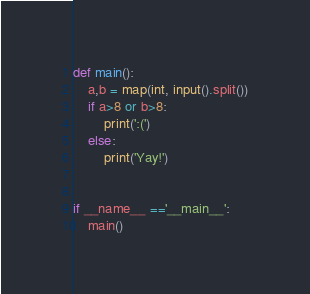<code> <loc_0><loc_0><loc_500><loc_500><_Python_>def main():
    a,b = map(int, input().split())
    if a>8 or b>8:
        print(':(')
    else:
        print('Yay!')


if __name__ =='__main__':
    main()
</code> 